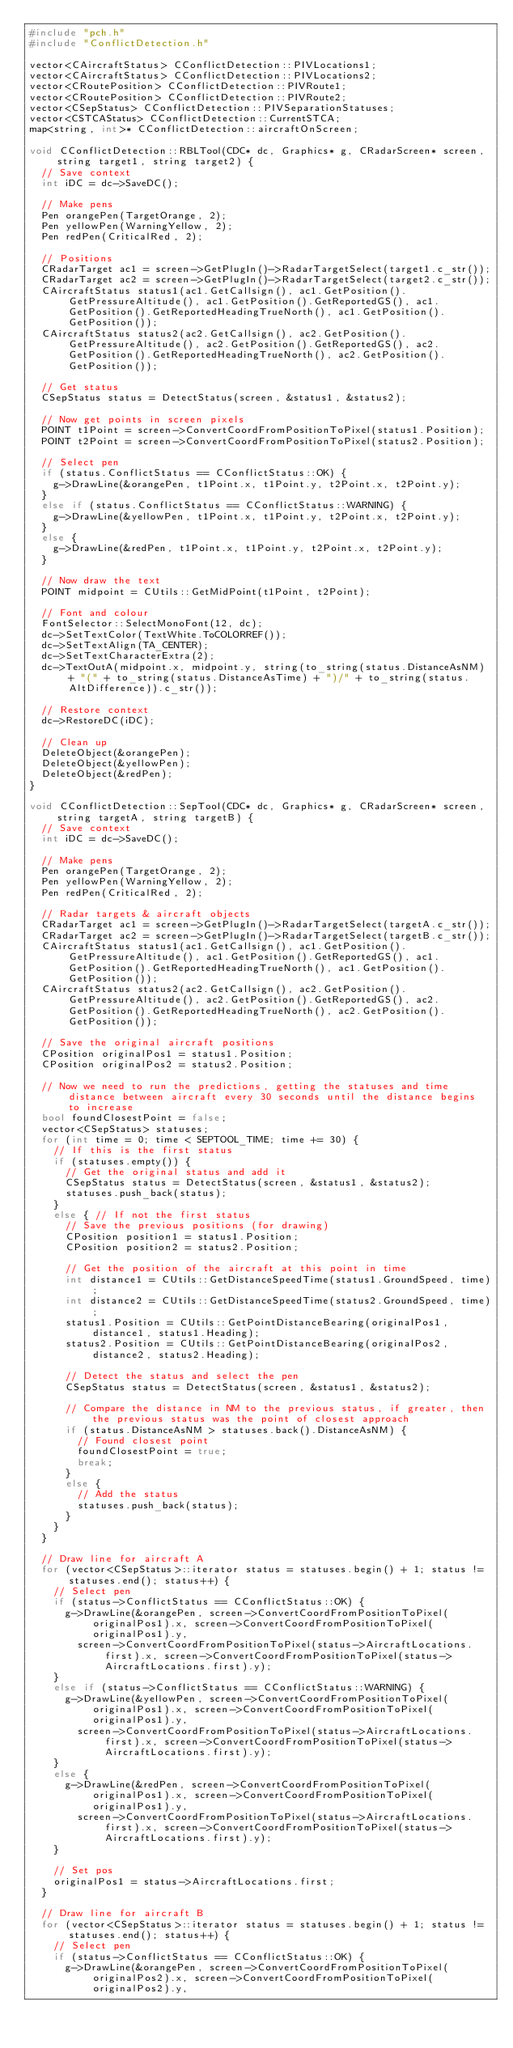Convert code to text. <code><loc_0><loc_0><loc_500><loc_500><_C++_>#include "pch.h"
#include "ConflictDetection.h"

vector<CAircraftStatus> CConflictDetection::PIVLocations1;
vector<CAircraftStatus> CConflictDetection::PIVLocations2;
vector<CRoutePosition> CConflictDetection::PIVRoute1;
vector<CRoutePosition> CConflictDetection::PIVRoute2;
vector<CSepStatus> CConflictDetection::PIVSeparationStatuses;
vector<CSTCAStatus> CConflictDetection::CurrentSTCA;
map<string, int>* CConflictDetection::aircraftOnScreen;

void CConflictDetection::RBLTool(CDC* dc, Graphics* g, CRadarScreen* screen, string target1, string target2) {
	// Save context
	int iDC = dc->SaveDC();

	// Make pens
	Pen orangePen(TargetOrange, 2);
	Pen yellowPen(WarningYellow, 2);
	Pen redPen(CriticalRed, 2);

	// Positions
	CRadarTarget ac1 = screen->GetPlugIn()->RadarTargetSelect(target1.c_str());
	CRadarTarget ac2 = screen->GetPlugIn()->RadarTargetSelect(target2.c_str());
	CAircraftStatus status1(ac1.GetCallsign(), ac1.GetPosition().GetPressureAltitude(), ac1.GetPosition().GetReportedGS(), ac1.GetPosition().GetReportedHeadingTrueNorth(), ac1.GetPosition().GetPosition());
	CAircraftStatus status2(ac2.GetCallsign(), ac2.GetPosition().GetPressureAltitude(), ac2.GetPosition().GetReportedGS(), ac2.GetPosition().GetReportedHeadingTrueNorth(), ac2.GetPosition().GetPosition());

	// Get status
	CSepStatus status = DetectStatus(screen, &status1, &status2);

	// Now get points in screen pixels
	POINT t1Point = screen->ConvertCoordFromPositionToPixel(status1.Position);
	POINT t2Point = screen->ConvertCoordFromPositionToPixel(status2.Position);

	// Select pen
	if (status.ConflictStatus == CConflictStatus::OK) {
		g->DrawLine(&orangePen, t1Point.x, t1Point.y, t2Point.x, t2Point.y);
	}
	else if (status.ConflictStatus == CConflictStatus::WARNING) {
		g->DrawLine(&yellowPen, t1Point.x, t1Point.y, t2Point.x, t2Point.y);
	}
	else {
		g->DrawLine(&redPen, t1Point.x, t1Point.y, t2Point.x, t2Point.y);
	}

	// Now draw the text
	POINT midpoint = CUtils::GetMidPoint(t1Point, t2Point);

	// Font and colour
	FontSelector::SelectMonoFont(12, dc);
	dc->SetTextColor(TextWhite.ToCOLORREF());
	dc->SetTextAlign(TA_CENTER);
	dc->SetTextCharacterExtra(2);
	dc->TextOutA(midpoint.x, midpoint.y, string(to_string(status.DistanceAsNM) + "(" + to_string(status.DistanceAsTime) + ")/" + to_string(status.AltDifference)).c_str());

	// Restore context
	dc->RestoreDC(iDC);

	// Clean up
	DeleteObject(&orangePen);
	DeleteObject(&yellowPen);
	DeleteObject(&redPen);
}

void CConflictDetection::SepTool(CDC* dc, Graphics* g, CRadarScreen* screen, string targetA, string targetB) {
	// Save context
	int iDC = dc->SaveDC();

	// Make pens
	Pen orangePen(TargetOrange, 2);
	Pen yellowPen(WarningYellow, 2);
	Pen redPen(CriticalRed, 2);

	// Radar targets & aircraft objects
	CRadarTarget ac1 = screen->GetPlugIn()->RadarTargetSelect(targetA.c_str());
	CRadarTarget ac2 = screen->GetPlugIn()->RadarTargetSelect(targetB.c_str());
	CAircraftStatus status1(ac1.GetCallsign(), ac1.GetPosition().GetPressureAltitude(), ac1.GetPosition().GetReportedGS(), ac1.GetPosition().GetReportedHeadingTrueNorth(), ac1.GetPosition().GetPosition());
	CAircraftStatus status2(ac2.GetCallsign(), ac2.GetPosition().GetPressureAltitude(), ac2.GetPosition().GetReportedGS(), ac2.GetPosition().GetReportedHeadingTrueNorth(), ac2.GetPosition().GetPosition());

	// Save the original aircraft positions
	CPosition originalPos1 = status1.Position;
	CPosition originalPos2 = status2.Position;

	// Now we need to run the predictions, getting the statuses and time distance between aircraft every 30 seconds until the distance begins to increase
	bool foundClosestPoint = false;
	vector<CSepStatus> statuses;
	for (int time = 0; time < SEPTOOL_TIME; time += 30) {
		// If this is the first status
		if (statuses.empty()) {
			// Get the original status and add it
			CSepStatus status = DetectStatus(screen, &status1, &status2);
			statuses.push_back(status);
		}
		else { // If not the first status
			// Save the previous positions (for drawing)
			CPosition position1 = status1.Position;
			CPosition position2 = status2.Position;

			// Get the position of the aircraft at this point in time
			int distance1 = CUtils::GetDistanceSpeedTime(status1.GroundSpeed, time);
			int distance2 = CUtils::GetDistanceSpeedTime(status2.GroundSpeed, time);
			status1.Position = CUtils::GetPointDistanceBearing(originalPos1, distance1, status1.Heading);
			status2.Position = CUtils::GetPointDistanceBearing(originalPos2, distance2, status2.Heading);

			// Detect the status and select the pen
			CSepStatus status = DetectStatus(screen, &status1, &status2);

			// Compare the distance in NM to the previous status, if greater, then the previous status was the point of closest approach
			if (status.DistanceAsNM > statuses.back().DistanceAsNM) {
				// Found closest point
				foundClosestPoint = true;
				break;
			}
			else {
				// Add the status
				statuses.push_back(status);
			}
		}
	}

	// Draw line for aircraft A
	for (vector<CSepStatus>::iterator status = statuses.begin() + 1; status != statuses.end(); status++) {
		// Select pen
		if (status->ConflictStatus == CConflictStatus::OK) {
			g->DrawLine(&orangePen, screen->ConvertCoordFromPositionToPixel(originalPos1).x, screen->ConvertCoordFromPositionToPixel(originalPos1).y,
				screen->ConvertCoordFromPositionToPixel(status->AircraftLocations.first).x, screen->ConvertCoordFromPositionToPixel(status->AircraftLocations.first).y);
		}
		else if (status->ConflictStatus == CConflictStatus::WARNING) {
			g->DrawLine(&yellowPen, screen->ConvertCoordFromPositionToPixel(originalPos1).x, screen->ConvertCoordFromPositionToPixel(originalPos1).y,
				screen->ConvertCoordFromPositionToPixel(status->AircraftLocations.first).x, screen->ConvertCoordFromPositionToPixel(status->AircraftLocations.first).y);
		}
		else {
			g->DrawLine(&redPen, screen->ConvertCoordFromPositionToPixel(originalPos1).x, screen->ConvertCoordFromPositionToPixel(originalPos1).y,
				screen->ConvertCoordFromPositionToPixel(status->AircraftLocations.first).x, screen->ConvertCoordFromPositionToPixel(status->AircraftLocations.first).y);
		}

		// Set pos
		originalPos1 = status->AircraftLocations.first;
	}

	// Draw line for aircraft B
	for (vector<CSepStatus>::iterator status = statuses.begin() + 1; status != statuses.end(); status++) {
		// Select pen
		if (status->ConflictStatus == CConflictStatus::OK) {
			g->DrawLine(&orangePen, screen->ConvertCoordFromPositionToPixel(originalPos2).x, screen->ConvertCoordFromPositionToPixel(originalPos2).y,</code> 